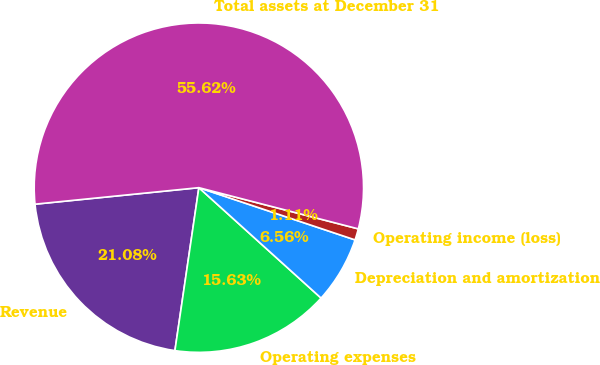<chart> <loc_0><loc_0><loc_500><loc_500><pie_chart><fcel>Revenue<fcel>Operating expenses<fcel>Depreciation and amortization<fcel>Operating income (loss)<fcel>Total assets at December 31<nl><fcel>21.08%<fcel>15.63%<fcel>6.56%<fcel>1.11%<fcel>55.63%<nl></chart> 